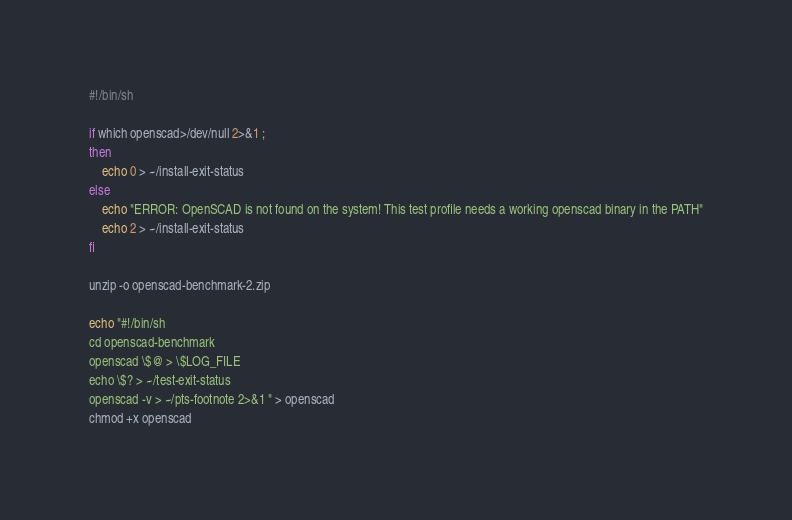Convert code to text. <code><loc_0><loc_0><loc_500><loc_500><_Bash_>#!/bin/sh

if which openscad>/dev/null 2>&1 ;
then
	echo 0 > ~/install-exit-status
else
	echo "ERROR: OpenSCAD is not found on the system! This test profile needs a working openscad binary in the PATH"
	echo 2 > ~/install-exit-status
fi

unzip -o openscad-benchmark-2.zip

echo "#!/bin/sh
cd openscad-benchmark
openscad \$@ > \$LOG_FILE
echo \$? > ~/test-exit-status
openscad -v > ~/pts-footnote 2>&1 " > openscad
chmod +x openscad
</code> 